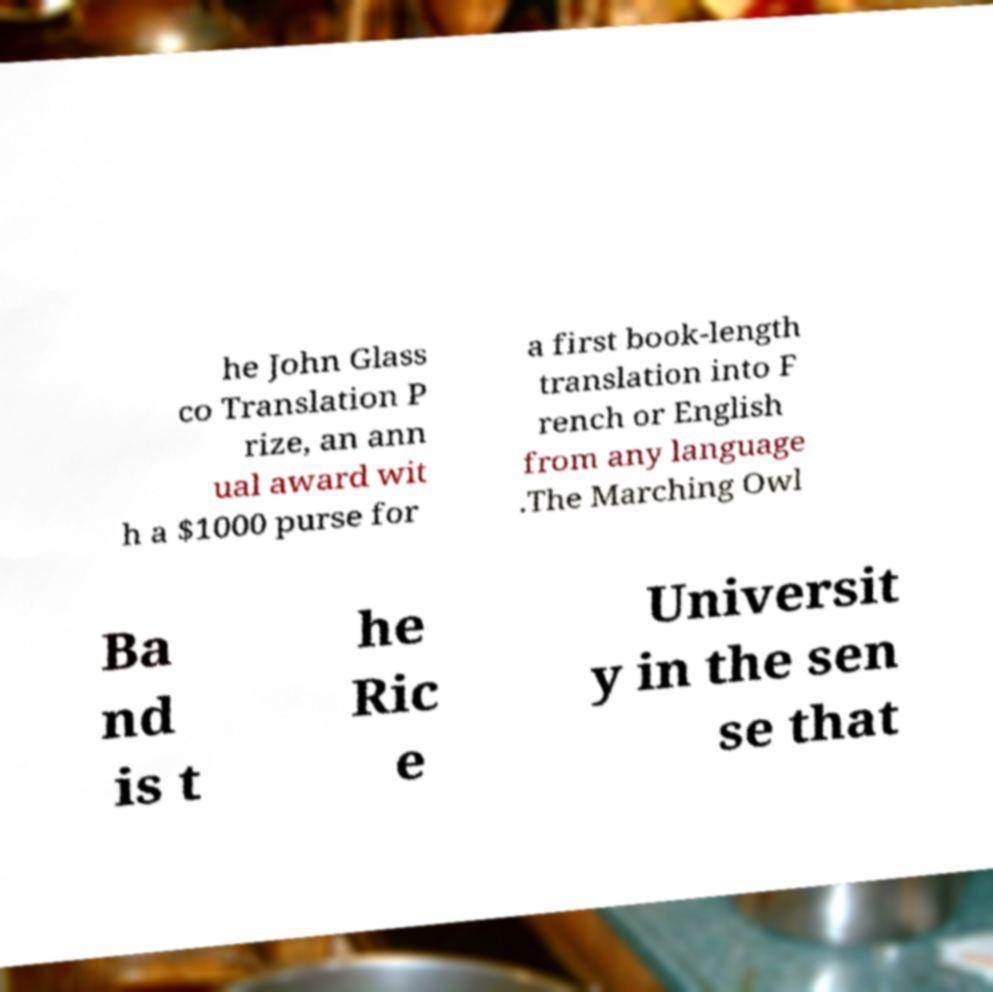What messages or text are displayed in this image? I need them in a readable, typed format. he John Glass co Translation P rize, an ann ual award wit h a $1000 purse for a first book-length translation into F rench or English from any language .The Marching Owl Ba nd is t he Ric e Universit y in the sen se that 